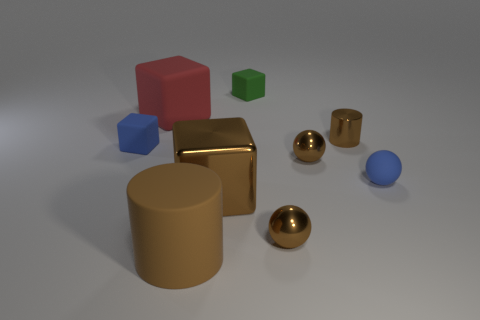There is a big red object; is it the same shape as the blue thing that is on the left side of the big shiny thing?
Provide a succinct answer. Yes. There is a large cylinder to the left of the brown metal object that is to the left of the small green object that is behind the small metallic cylinder; what color is it?
Your answer should be very brief. Brown. Are there any blue matte things left of the blue matte cube?
Offer a terse response. No. There is a metal block that is the same color as the big matte cylinder; what is its size?
Ensure brevity in your answer.  Large. Is there a small red object that has the same material as the blue cube?
Keep it short and to the point. No. The small matte ball has what color?
Your answer should be very brief. Blue. Do the big thing behind the rubber sphere and the big metal thing have the same shape?
Provide a succinct answer. Yes. There is a tiny thing to the left of the rubber object that is in front of the large cube in front of the blue rubber cube; what shape is it?
Your answer should be compact. Cube. There is a brown cylinder that is behind the tiny blue block; what is it made of?
Provide a short and direct response. Metal. What is the color of the metallic block that is the same size as the brown rubber thing?
Your response must be concise. Brown. 